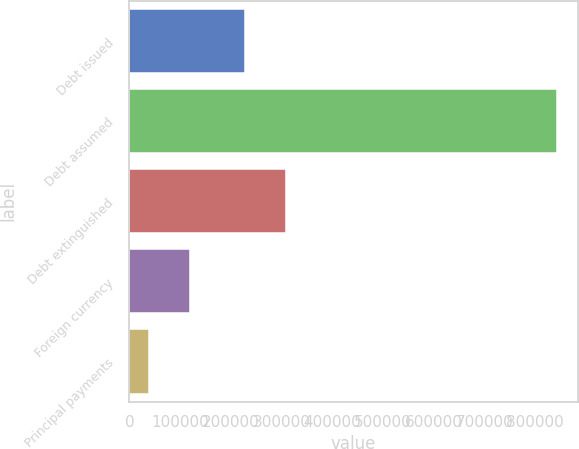Convert chart to OTSL. <chart><loc_0><loc_0><loc_500><loc_500><bar_chart><fcel>Debt issued<fcel>Debt assumed<fcel>Debt extinguished<fcel>Foreign currency<fcel>Principal payments<nl><fcel>228685<fcel>842316<fcel>309048<fcel>119053<fcel>38690<nl></chart> 